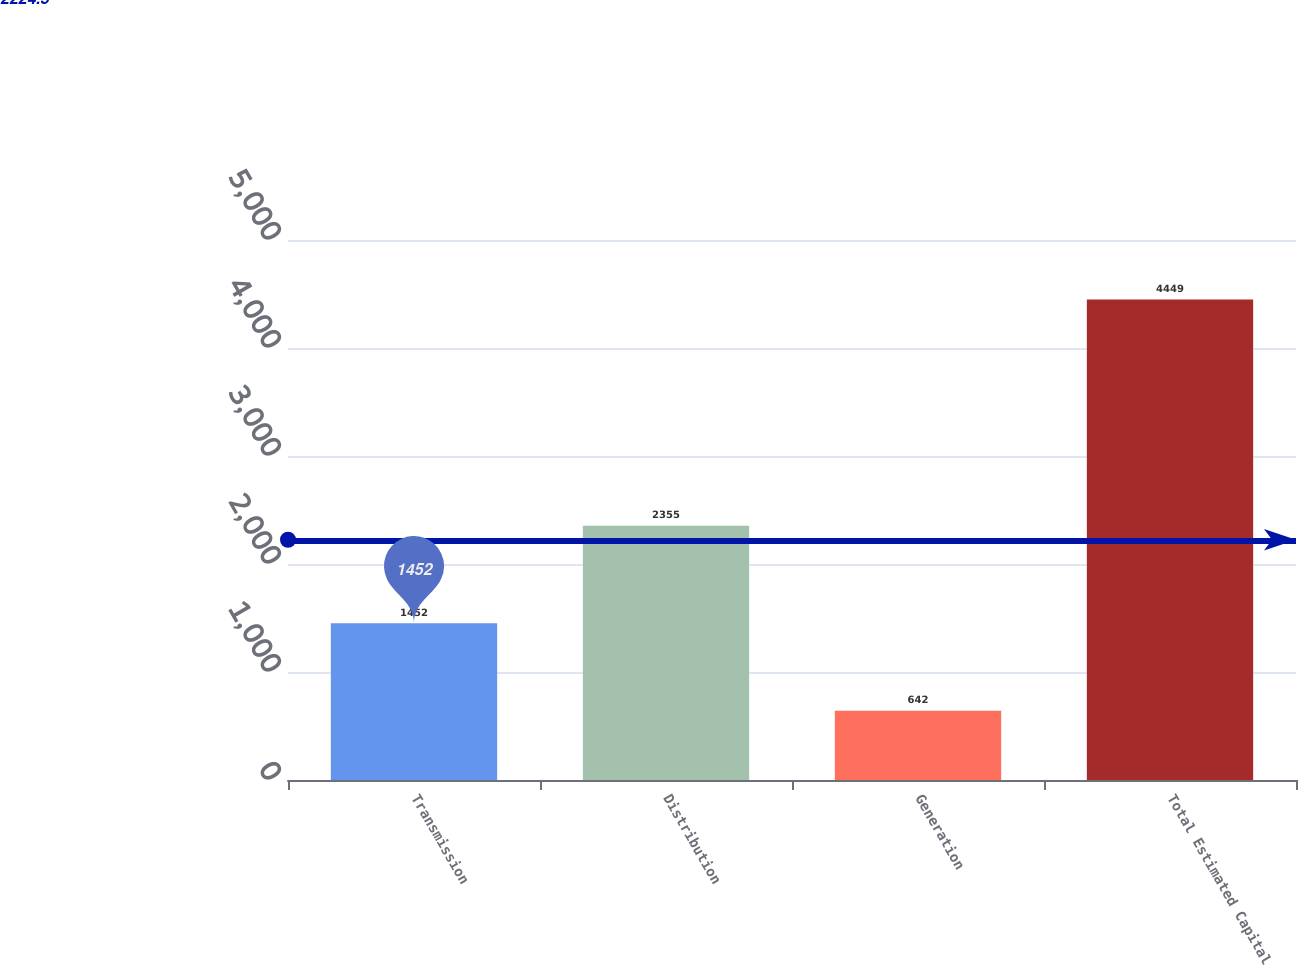Convert chart. <chart><loc_0><loc_0><loc_500><loc_500><bar_chart><fcel>Transmission<fcel>Distribution<fcel>Generation<fcel>Total Estimated Capital<nl><fcel>1452<fcel>2355<fcel>642<fcel>4449<nl></chart> 